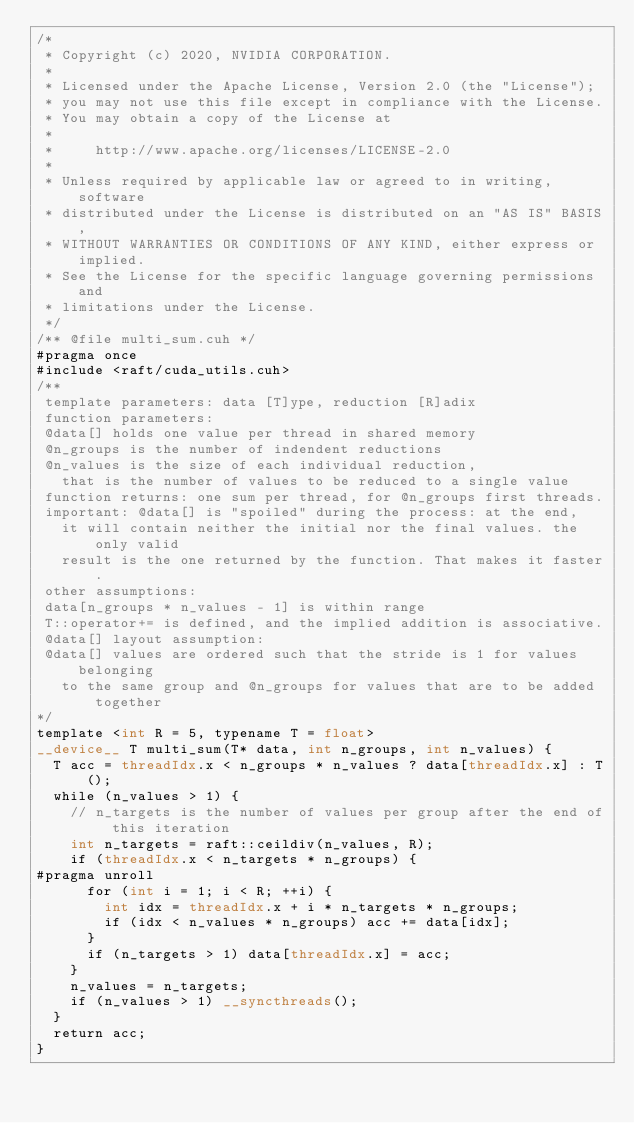Convert code to text. <code><loc_0><loc_0><loc_500><loc_500><_Cuda_>/*
 * Copyright (c) 2020, NVIDIA CORPORATION.
 *
 * Licensed under the Apache License, Version 2.0 (the "License");
 * you may not use this file except in compliance with the License.
 * You may obtain a copy of the License at
 *
 *     http://www.apache.org/licenses/LICENSE-2.0
 *
 * Unless required by applicable law or agreed to in writing, software
 * distributed under the License is distributed on an "AS IS" BASIS,
 * WITHOUT WARRANTIES OR CONDITIONS OF ANY KIND, either express or implied.
 * See the License for the specific language governing permissions and
 * limitations under the License.
 */
/** @file multi_sum.cuh */
#pragma once
#include <raft/cuda_utils.cuh>
/**
 template parameters: data [T]ype, reduction [R]adix
 function parameters:
 @data[] holds one value per thread in shared memory
 @n_groups is the number of indendent reductions
 @n_values is the size of each individual reduction,
   that is the number of values to be reduced to a single value
 function returns: one sum per thread, for @n_groups first threads.
 important: @data[] is "spoiled" during the process: at the end,
   it will contain neither the initial nor the final values. the only valid
   result is the one returned by the function. That makes it faster.
 other assumptions:
 data[n_groups * n_values - 1] is within range
 T::operator+= is defined, and the implied addition is associative.
 @data[] layout assumption:
 @data[] values are ordered such that the stride is 1 for values belonging
   to the same group and @n_groups for values that are to be added together
*/
template <int R = 5, typename T = float>
__device__ T multi_sum(T* data, int n_groups, int n_values) {
  T acc = threadIdx.x < n_groups * n_values ? data[threadIdx.x] : T();
  while (n_values > 1) {
    // n_targets is the number of values per group after the end of this iteration
    int n_targets = raft::ceildiv(n_values, R);
    if (threadIdx.x < n_targets * n_groups) {
#pragma unroll
      for (int i = 1; i < R; ++i) {
        int idx = threadIdx.x + i * n_targets * n_groups;
        if (idx < n_values * n_groups) acc += data[idx];
      }
      if (n_targets > 1) data[threadIdx.x] = acc;
    }
    n_values = n_targets;
    if (n_values > 1) __syncthreads();
  }
  return acc;
}
</code> 